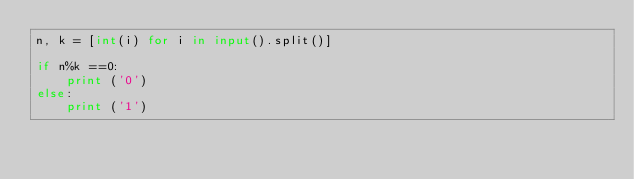Convert code to text. <code><loc_0><loc_0><loc_500><loc_500><_Python_>n, k = [int(i) for i in input().split()]

if n%k ==0:
    print ('0')
else:
    print ('1')
</code> 